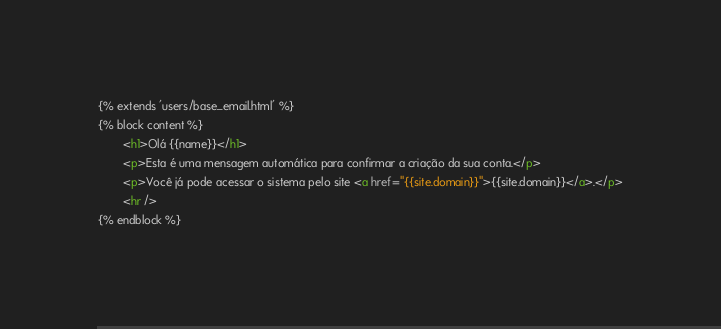Convert code to text. <code><loc_0><loc_0><loc_500><loc_500><_HTML_>{% extends 'users/base_email.html' %}
{% block content %}
		<h1>Olá {{name}}</h1>
		<p>Esta é uma mensagem automática para confirmar a criação da sua conta.</p>
		<p>Você já pode acessar o sistema pelo site <a href="{{site.domain}}">{{site.domain}}</a>.</p>
		<hr />
{% endblock %}</code> 